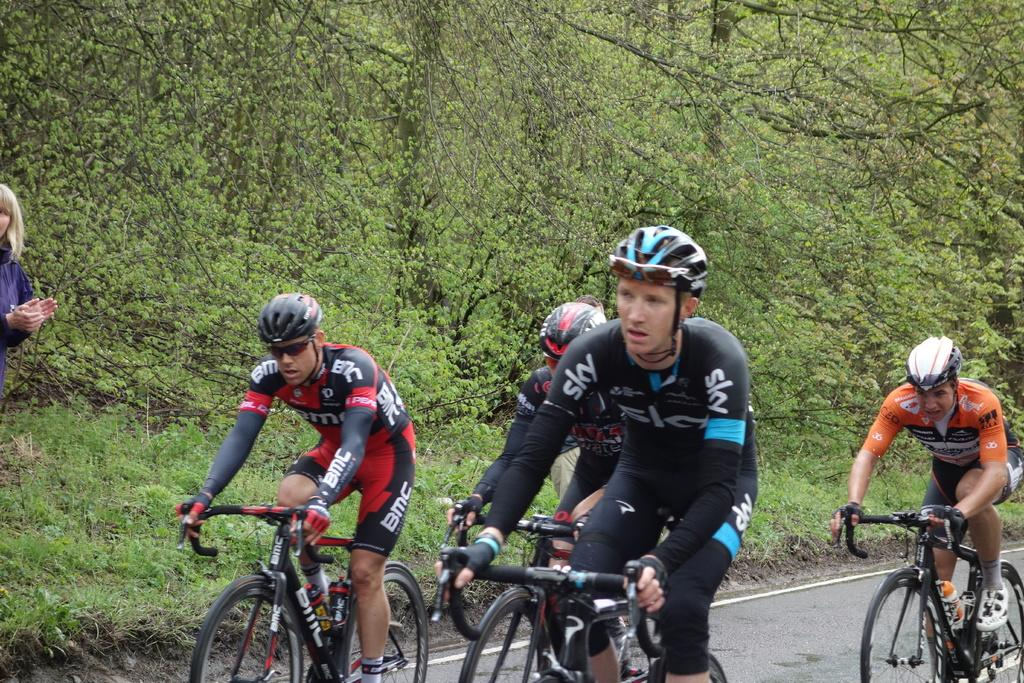Who is present in the image? There are people in the image. What are the people wearing on their heads? The people are wearing helmets. What activity are the people engaged in? The people are riding bicycles. What type of natural elements can be seen in the image? There are trees in the image. What type of vegetation is present on the floor? There are plants on the floor in the image. What type of cork can be seen floating in the image? There is no cork present in the image. How does the fog affect the visibility of the people in the image? There is no fog present in the image; it is clear and easy to see the people. 